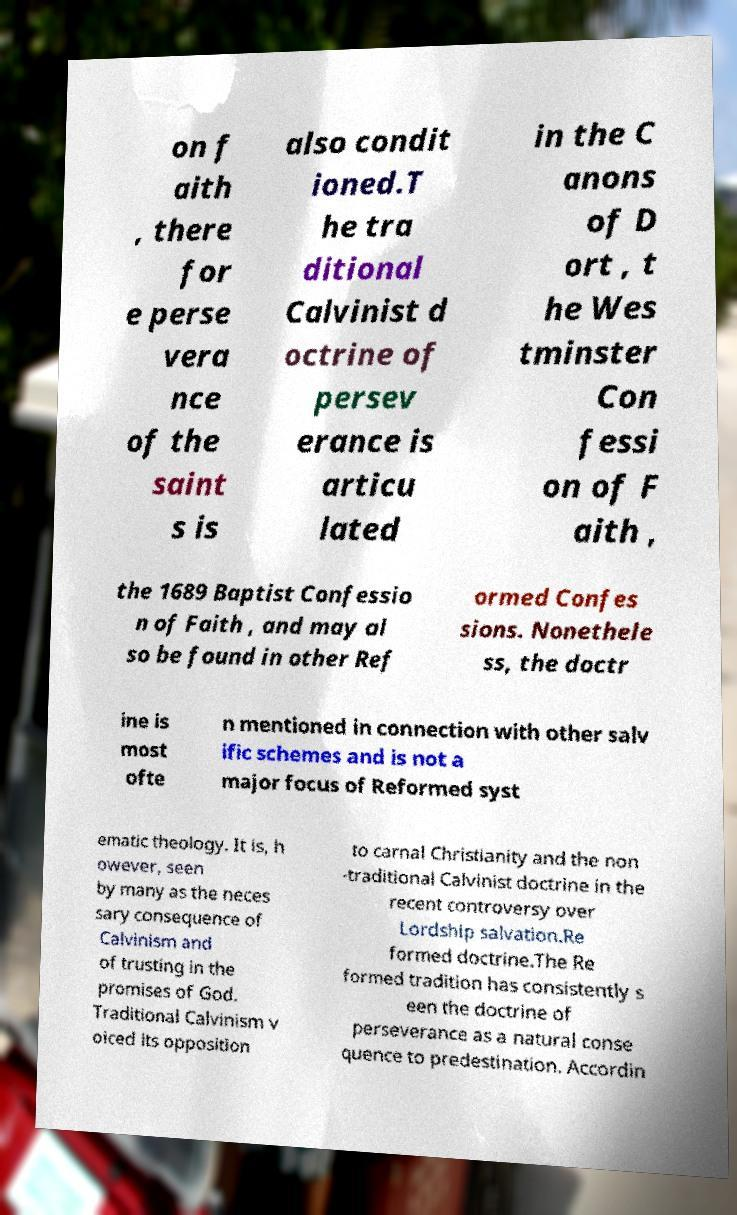Could you assist in decoding the text presented in this image and type it out clearly? on f aith , there for e perse vera nce of the saint s is also condit ioned.T he tra ditional Calvinist d octrine of persev erance is articu lated in the C anons of D ort , t he Wes tminster Con fessi on of F aith , the 1689 Baptist Confessio n of Faith , and may al so be found in other Ref ormed Confes sions. Nonethele ss, the doctr ine is most ofte n mentioned in connection with other salv ific schemes and is not a major focus of Reformed syst ematic theology. It is, h owever, seen by many as the neces sary consequence of Calvinism and of trusting in the promises of God. Traditional Calvinism v oiced its opposition to carnal Christianity and the non -traditional Calvinist doctrine in the recent controversy over Lordship salvation.Re formed doctrine.The Re formed tradition has consistently s een the doctrine of perseverance as a natural conse quence to predestination. Accordin 